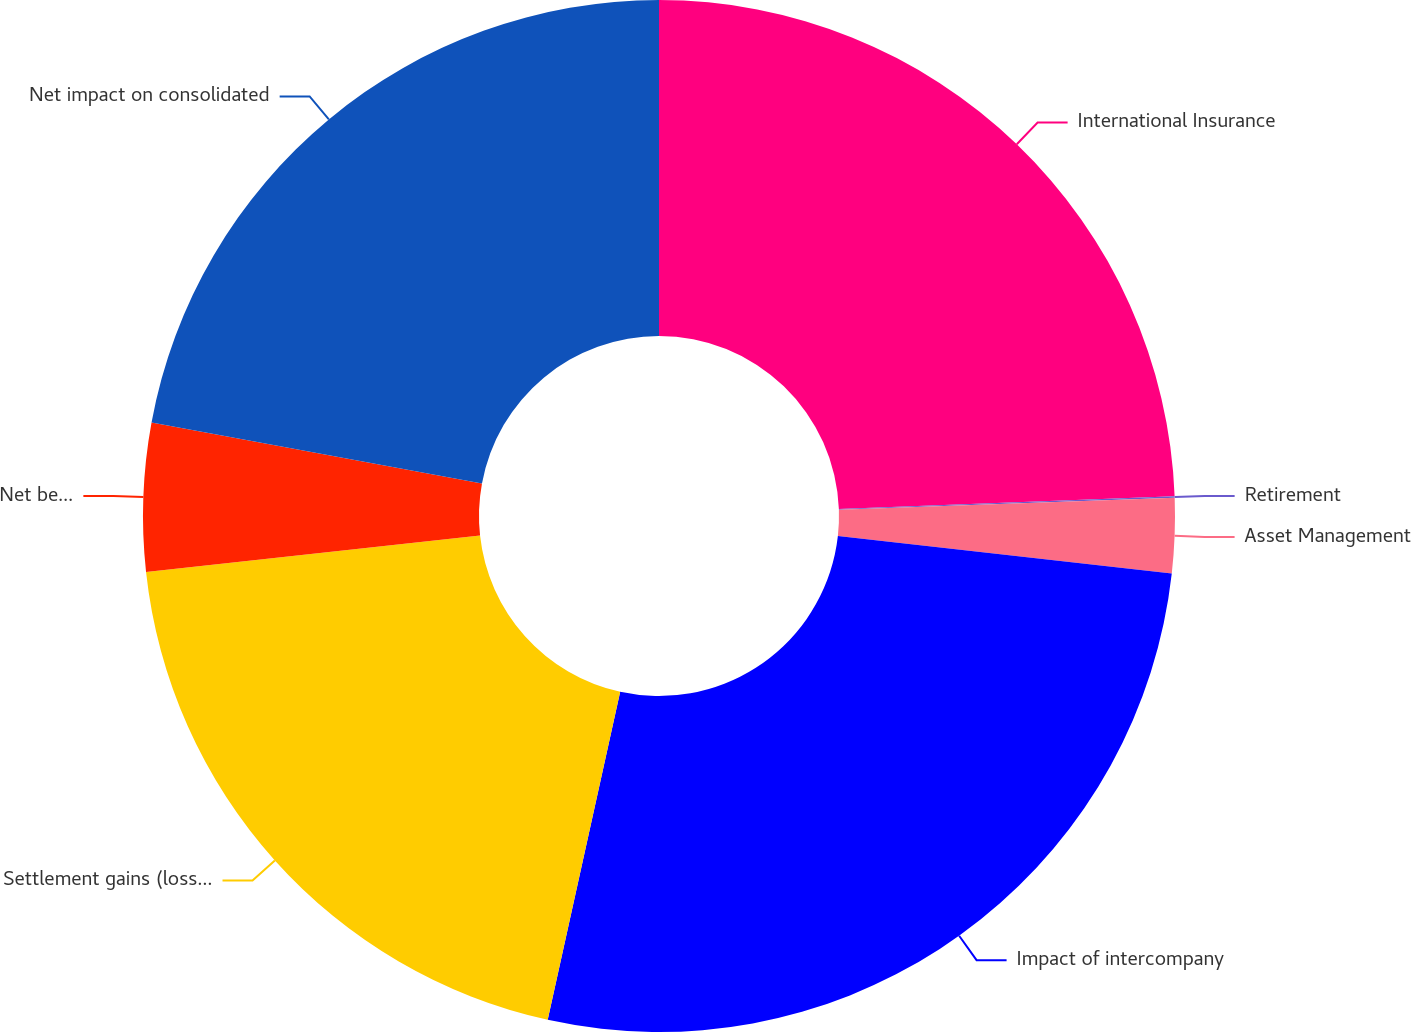Convert chart. <chart><loc_0><loc_0><loc_500><loc_500><pie_chart><fcel>International Insurance<fcel>Retirement<fcel>Asset Management<fcel>Impact of intercompany<fcel>Settlement gains (losses) on<fcel>Net benefit (detriment) to<fcel>Net impact on consolidated<nl><fcel>24.39%<fcel>0.05%<fcel>2.34%<fcel>26.68%<fcel>19.81%<fcel>4.63%<fcel>22.1%<nl></chart> 